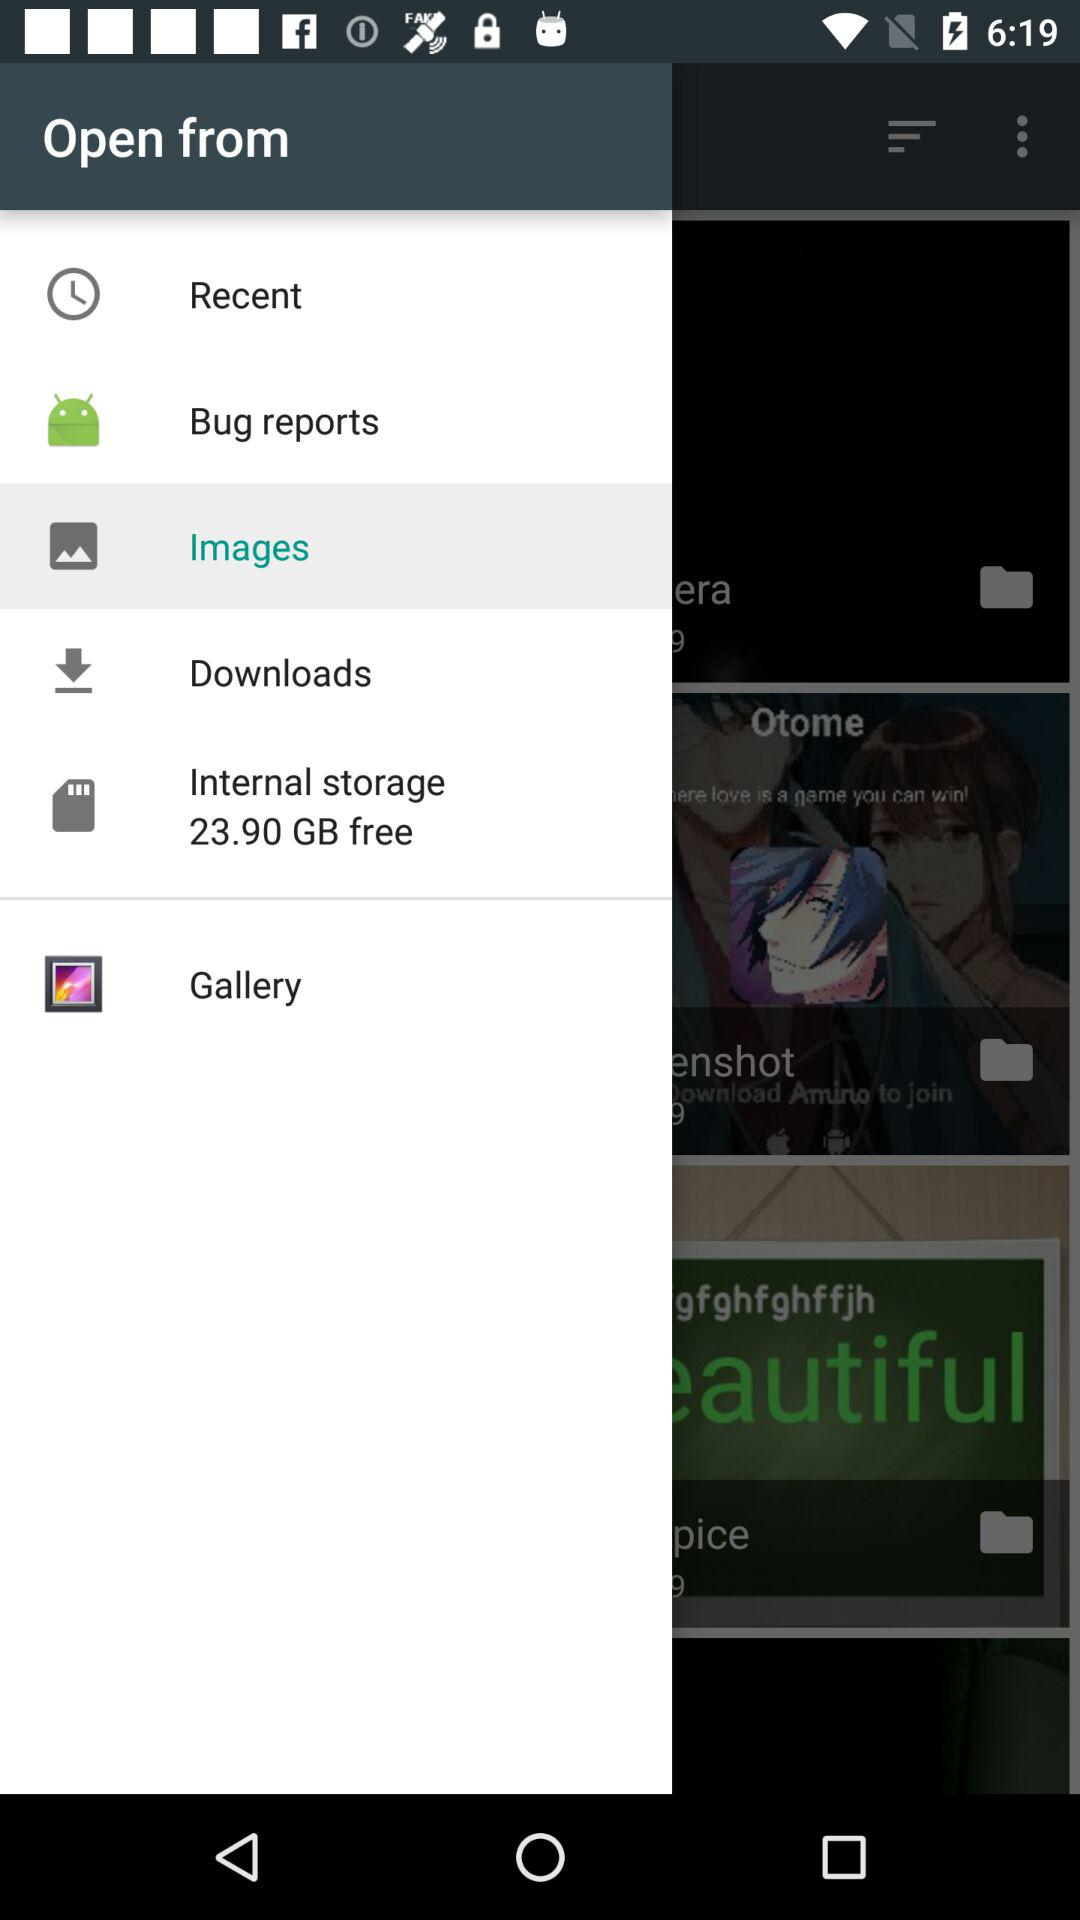How much internal storage space is available? Internal storage space of 23.90 GB is available. 